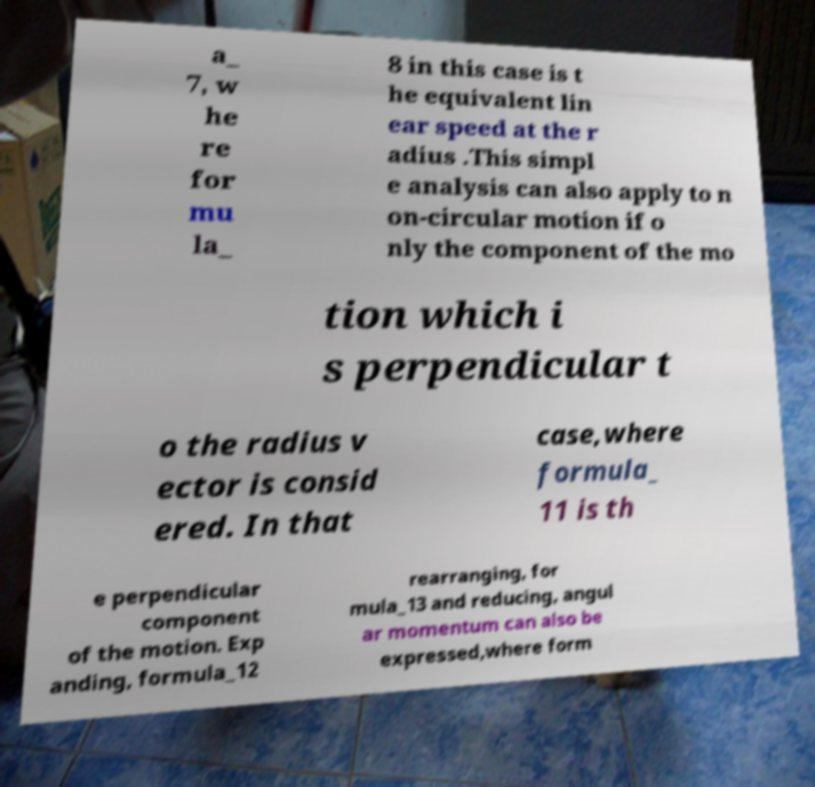Please identify and transcribe the text found in this image. a_ 7, w he re for mu la_ 8 in this case is t he equivalent lin ear speed at the r adius .This simpl e analysis can also apply to n on-circular motion if o nly the component of the mo tion which i s perpendicular t o the radius v ector is consid ered. In that case,where formula_ 11 is th e perpendicular component of the motion. Exp anding, formula_12 rearranging, for mula_13 and reducing, angul ar momentum can also be expressed,where form 